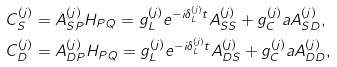Convert formula to latex. <formula><loc_0><loc_0><loc_500><loc_500>C _ { S } ^ { ( j ) } & = A _ { S P } ^ { ( j ) } H _ { P Q } = g _ { L } ^ { ( j ) } e ^ { - i \delta _ { L } ^ { ( j ) } t } A _ { S S } ^ { ( j ) } + g _ { C } ^ { ( j ) } a A _ { S D } ^ { ( j ) } , \\ C _ { D } ^ { ( j ) } & = A _ { D P } ^ { ( j ) } H _ { P Q } = g _ { L } ^ { ( j ) } e ^ { - i \delta _ { L } ^ { ( j ) } t } A _ { D S } ^ { ( j ) } + g _ { C } ^ { ( j ) } a A _ { D D } ^ { ( j ) } ,</formula> 